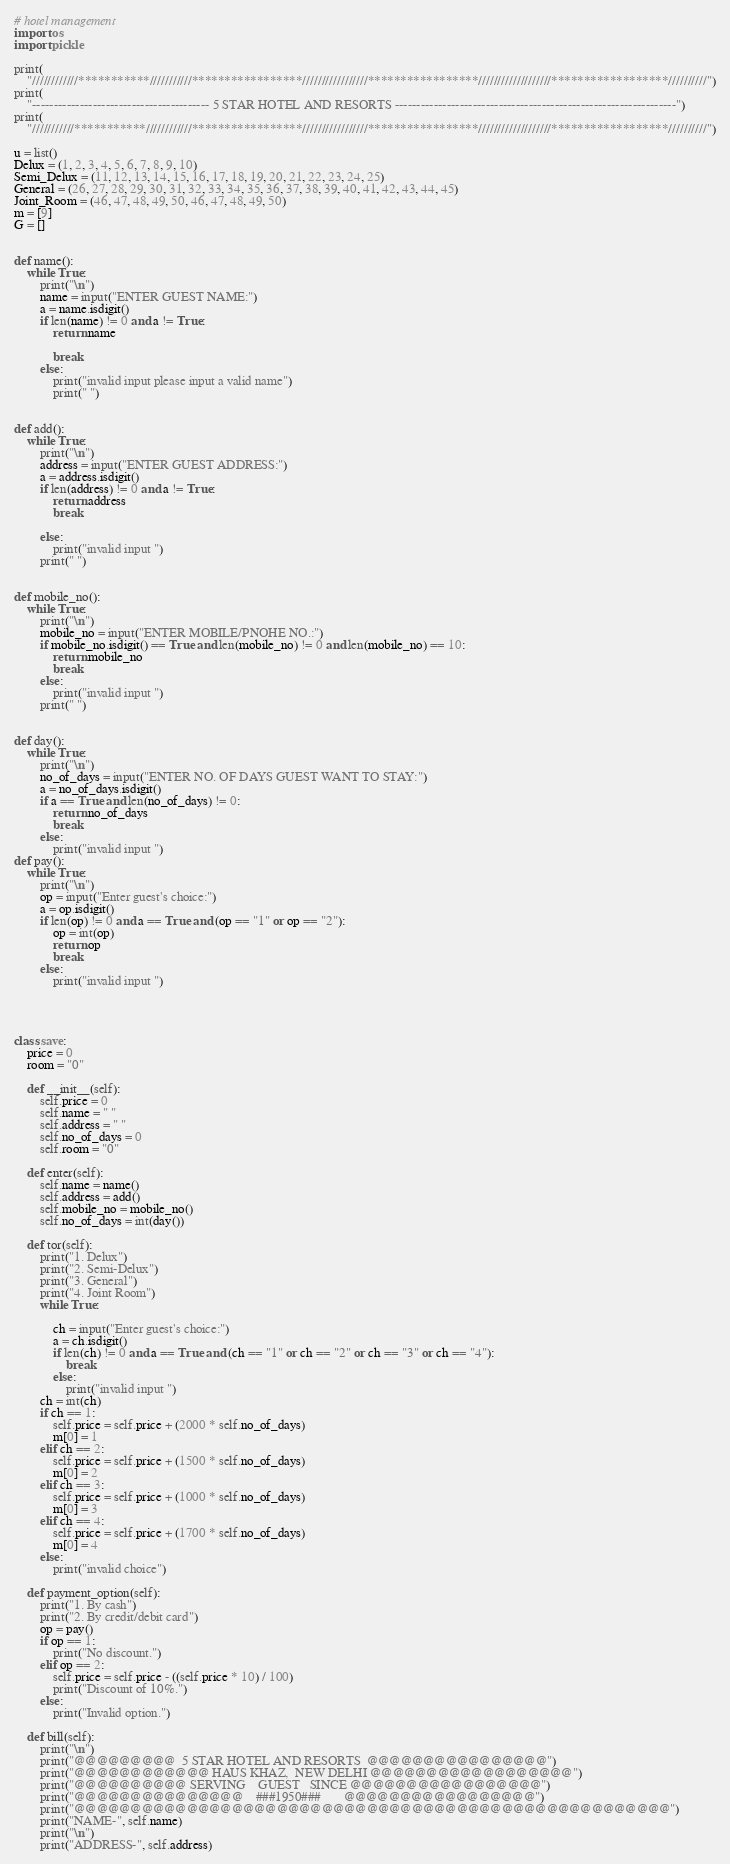Convert code to text. <code><loc_0><loc_0><loc_500><loc_500><_Python_># hotel management
import os
import pickle

print(
    "////////////***********///////////*****************/////////////////*****************///////////////////******************//////////")
print(
    "----------------------------------------- 5 STAR HOTEL AND RESORTS -----------------------------------------------------------------")
print(
    "///////////***********////////////*****************/////////////////*****************///////////////////******************//////////")

u = list()
Delux = (1, 2, 3, 4, 5, 6, 7, 8, 9, 10)
Semi_Delux = (11, 12, 13, 14, 15, 16, 17, 18, 19, 20, 21, 22, 23, 24, 25)
General = (26, 27, 28, 29, 30, 31, 32, 33, 34, 35, 36, 37, 38, 39, 40, 41, 42, 43, 44, 45)
Joint_Room = (46, 47, 48, 49, 50, 46, 47, 48, 49, 50)
m = [9]
G = []


def name():
    while True:
        print("\n")
        name = input("ENTER GUEST NAME:")
        a = name.isdigit()
        if len(name) != 0 and a != True:
            return name

            break
        else:
            print("invalid input please input a valid name")
            print(" ")


def add():
    while True:
        print("\n")
        address = input("ENTER GUEST ADDRESS:")
        a = address.isdigit()
        if len(address) != 0 and a != True:
            return address
            break

        else:
            print("invalid input ")
        print(" ")


def mobile_no():
    while True:
        print("\n")
        mobile_no = input("ENTER MOBILE/PNOHE NO.:")
        if mobile_no.isdigit() == True and len(mobile_no) != 0 and len(mobile_no) == 10:
            return mobile_no
            break
        else:
            print("invalid input ")
        print(" ")


def day():
    while True:
        print("\n")
        no_of_days = input("ENTER NO. OF DAYS GUEST WANT TO STAY:")
        a = no_of_days.isdigit()
        if a == True and len(no_of_days) != 0:
            return no_of_days
            break
        else:
            print("invalid input ")
def pay():
    while True:
        print("\n")
        op = input("Enter guest's choice:")
        a = op.isdigit()
        if len(op) != 0 and a == True and (op == "1" or op == "2"):
            op = int(op)
            return op
            break
        else:
            print("invalid input ")




class save:
    price = 0
    room = "0"

    def __init__(self):
        self.price = 0
        self.name = " "
        self.address = " "
        self.no_of_days = 0
        self.room = "0"

    def enter(self):
        self.name = name()
        self.address = add()
        self.mobile_no = mobile_no()
        self.no_of_days = int(day())

    def tor(self):
        print("1. Delux")
        print("2. Semi-Delux")
        print("3. General")
        print("4. Joint Room")
        while True:
    
            ch = input("Enter guest's choice:")
            a = ch.isdigit()
            if len(ch) != 0 and a == True and (ch == "1" or ch == "2" or ch == "3" or ch == "4"):
                break
            else:
                print("invalid input ")
        ch = int(ch)
        if ch == 1:
            self.price = self.price + (2000 * self.no_of_days)
            m[0] = 1
        elif ch == 2:
            self.price = self.price + (1500 * self.no_of_days)
            m[0] = 2
        elif ch == 3:
            self.price = self.price + (1000 * self.no_of_days)
            m[0] = 3
        elif ch == 4:
            self.price = self.price + (1700 * self.no_of_days)
            m[0] = 4
        else:
            print("invalid choice")

    def payment_option(self):
        print("1. By cash")
        print("2. By credit/debit card")
        op = pay()
        if op == 1:
            print("No discount.")
        elif op == 2:
            self.price = self.price - ((self.price * 10) / 100)
            print("Discount of 10%.")
        else:
            print("Invalid option.")

    def bill(self):
        print("\n")
        print("@@@@@@@@@  5 STAR HOTEL AND RESORTS  @@@@@@@@@@@@@@@@")
        print("@@@@@@@@@@@@ HAUS KHAZ,  NEW DELHI @@@@@@@@@@@@@@@@@@")
        print("@@@@@@@@@@ SERVING    GUEST   SINCE @@@@@@@@@@@@@@@@@")
        print("@@@@@@@@@@@@@@@    ###1950###       @@@@@@@@@@@@@@@@@")
        print("@@@@@@@@@@@@@@@@@@@@@@@@@@@@@@@@@@@@@@@@@@@@@@@@@@@@@")
        print("NAME-", self.name)
        print("\n")
        print("ADDRESS-", self.address)</code> 